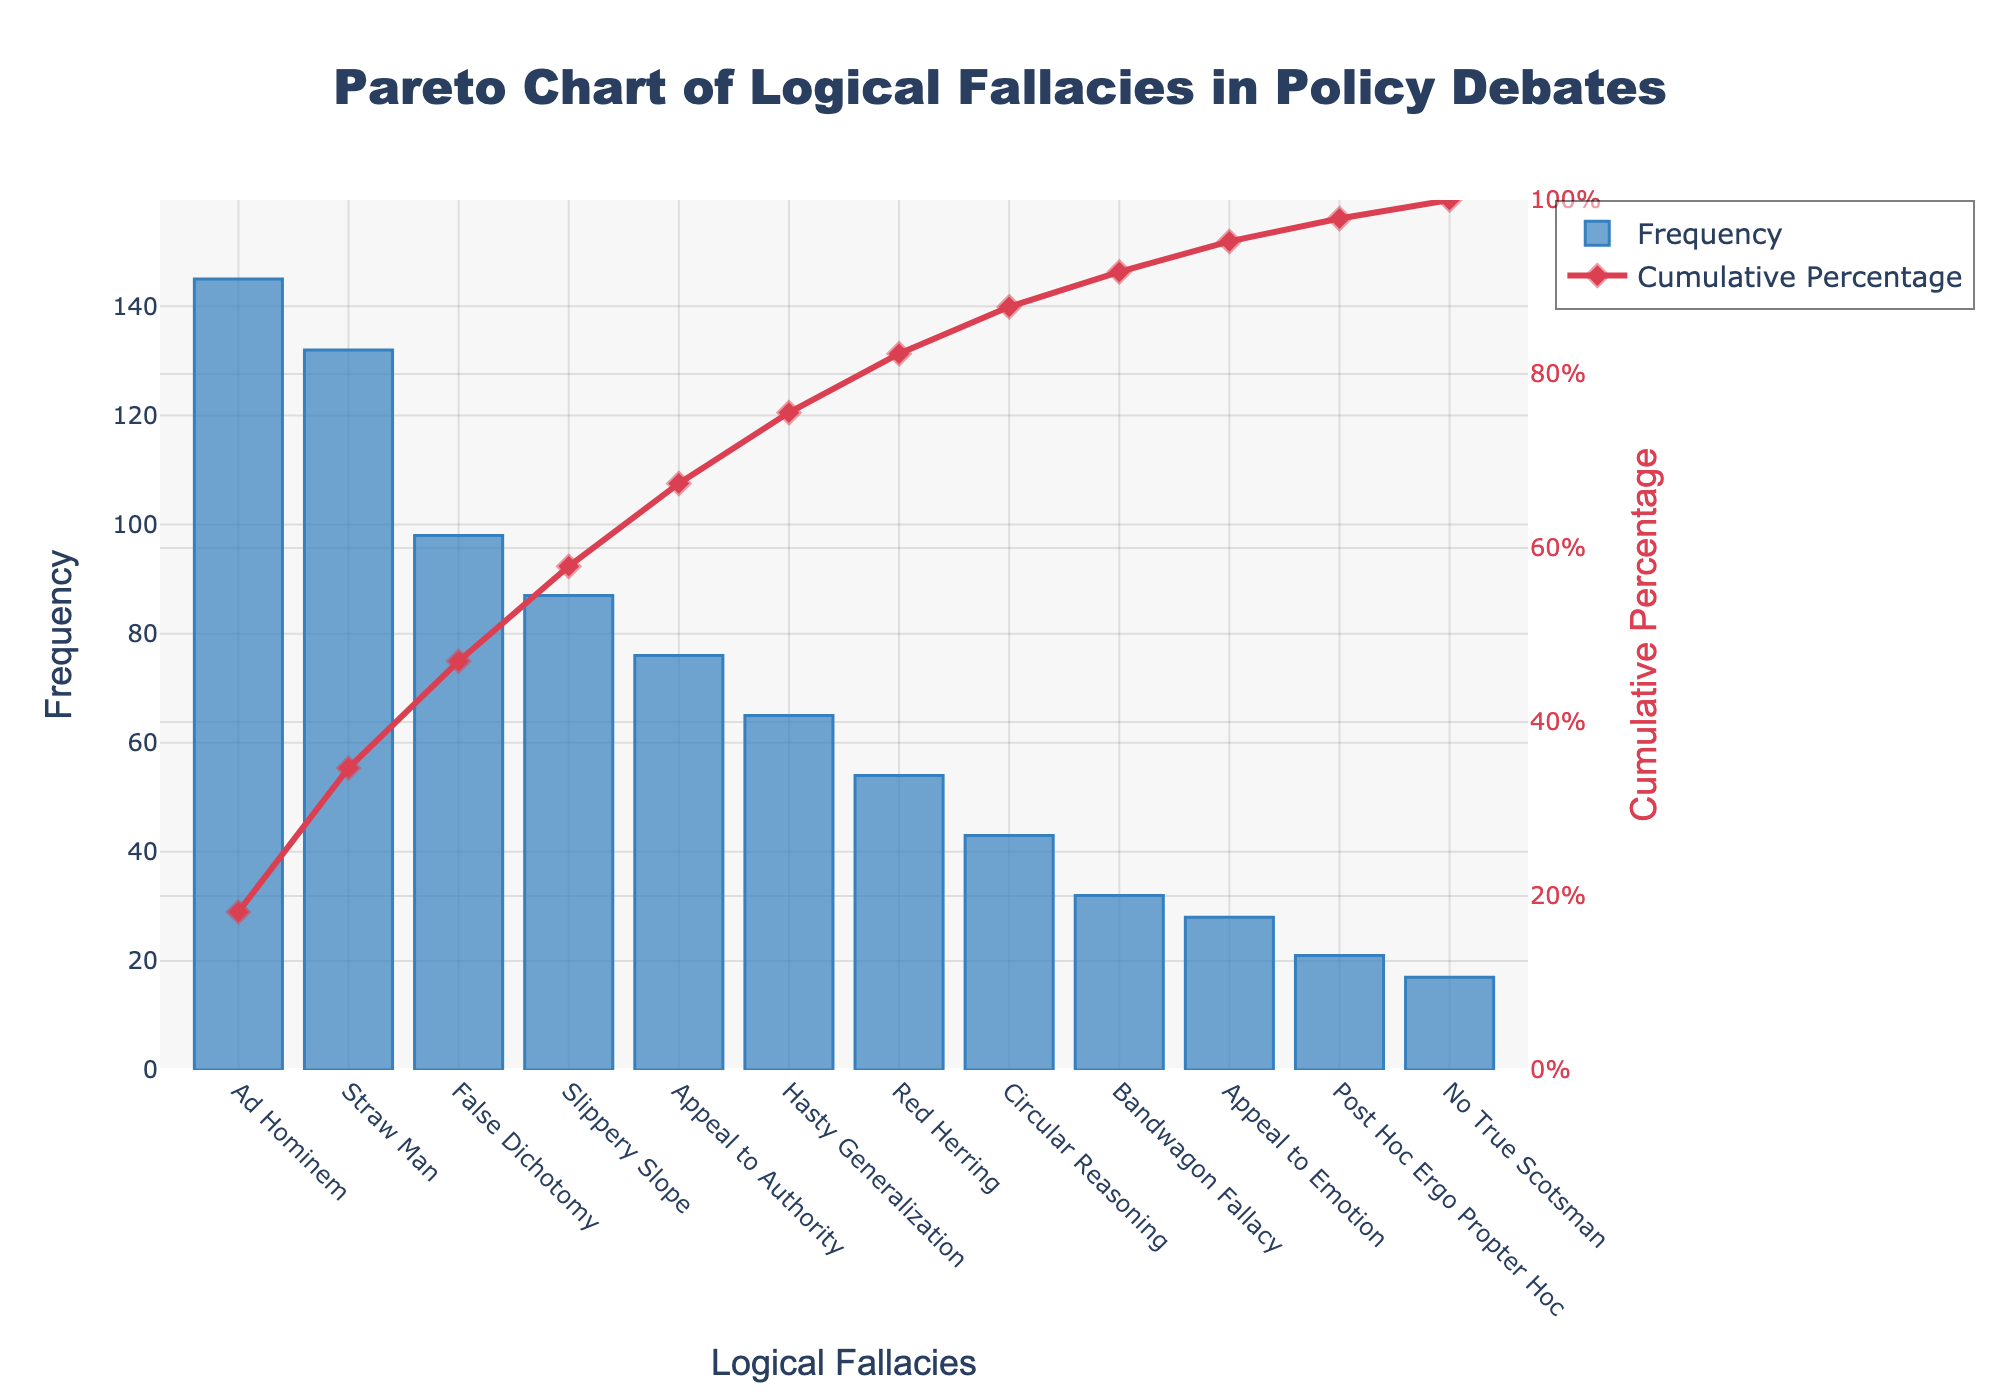What's the title of the chart? The title is displayed at the top of the Pareto chart. It provides a summary of what the chart is about. In this case, the title is "Pareto Chart of Logical Fallacies in Policy Debates".
Answer: Pareto Chart of Logical Fallacies in Policy Debates Which fallacy has the highest frequency? The highest frequency fallacy is the one whose bar segment is the tallest in the bar chart part of the Pareto chart; in this case, it is the "Ad Hominem" fallacy.
Answer: Ad Hominem What's the cumulative percentage of the top three fallacies? Sum the frequencies of the top three fallacies "Ad Hominem", "Straw Man", and "False Dichotomy", which are 145, 132, and 98 respectively, and then divide by the total frequency (698). Multiply by 100 to get the percentage.
Answer: 53.15% Compare the frequency of "Straw Man" and "Red Herring." Which is higher? By looking at the bar height of both fallacies, "Straw Man" is higher than "Red Herring". Therefore, "Straw Man" has a greater frequency.
Answer: Straw Man Which fallacies contribute to 80% of the total frequency? Add the frequencies of the fallacies sequentially until the cumulative percentage surpasses 80%. The fallacies contributing to 80% are "Ad Hominem", "Straw Man", "False Dichotomy", "Slippery Slope", "Appeal to Authority", "Hasty Generalization", and a portion of the "Red Herring" fallacy (93.7 cumulative percentage minus 80 gives approximately 3.7%, which means part of "Red Herring").
Answer: Ad Hominem, Straw Man, False Dichotomy, Slippery Slope, Appeal to Authority, Hasty Generalization What's the frequency difference between "Circular Reasoning" and "Bandwagon Fallacy"? By subtracting the frequency of "Bandwagon Fallacy" from that of "Circular Reasoning" (43 - 32), you get the difference.
Answer: 11 How many logical fallacies are listed in total? Count the number of different fallacies represented by their respective bars on the x-axis.
Answer: 11 Does the cumulative percentage line reach 100%? The cumulative percentage line will reach 100% since the line always represents the cumulative sum from 0 to the total 100%.
Answer: Yes Which side of the chart does the cumulative percentage appear on? The cumulative percentage line is marked on the right y-axis of the chart.
Answer: Right side What is the frequency of "Post Hoc Ergo Propter Hoc"? The specific bar for "Post Hoc Ergo Propter Hoc" represents the frequency with a height indicating the value is 21.
Answer: 21 